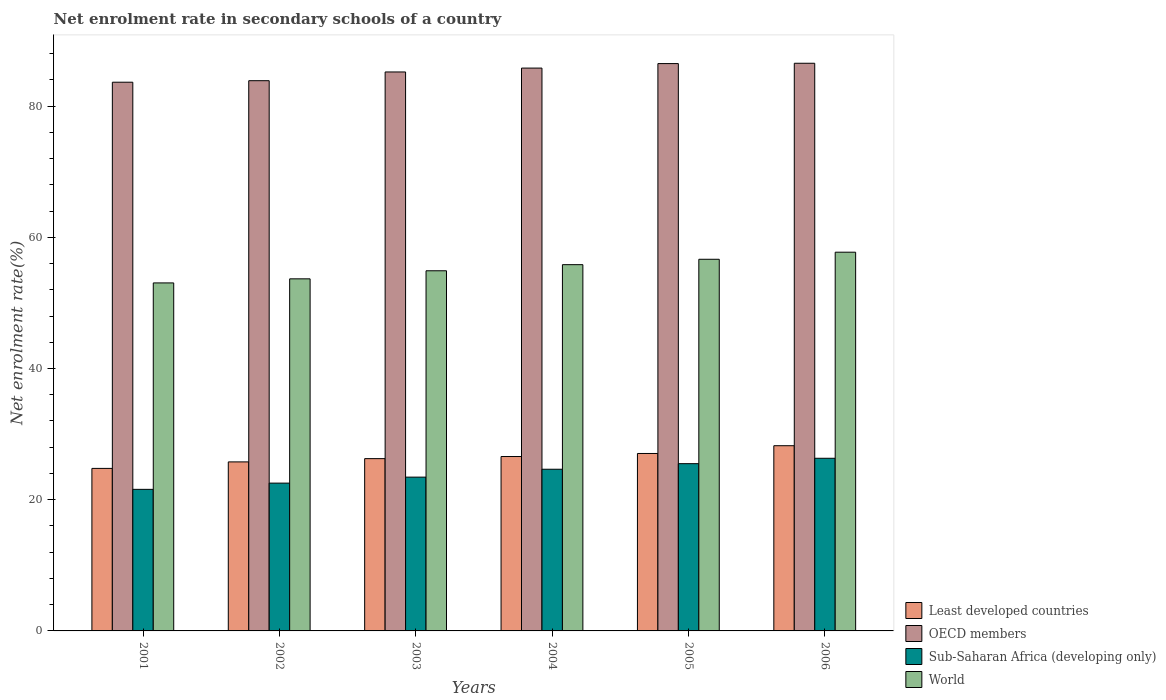How many groups of bars are there?
Your answer should be very brief. 6. Are the number of bars on each tick of the X-axis equal?
Provide a short and direct response. Yes. How many bars are there on the 2nd tick from the left?
Give a very brief answer. 4. How many bars are there on the 3rd tick from the right?
Ensure brevity in your answer.  4. What is the label of the 2nd group of bars from the left?
Provide a short and direct response. 2002. What is the net enrolment rate in secondary schools in Sub-Saharan Africa (developing only) in 2005?
Your answer should be very brief. 25.5. Across all years, what is the maximum net enrolment rate in secondary schools in Sub-Saharan Africa (developing only)?
Your answer should be compact. 26.32. Across all years, what is the minimum net enrolment rate in secondary schools in OECD members?
Give a very brief answer. 83.64. In which year was the net enrolment rate in secondary schools in World maximum?
Keep it short and to the point. 2006. In which year was the net enrolment rate in secondary schools in World minimum?
Keep it short and to the point. 2001. What is the total net enrolment rate in secondary schools in OECD members in the graph?
Offer a terse response. 511.53. What is the difference between the net enrolment rate in secondary schools in OECD members in 2004 and that in 2005?
Give a very brief answer. -0.69. What is the difference between the net enrolment rate in secondary schools in Least developed countries in 2002 and the net enrolment rate in secondary schools in World in 2004?
Make the answer very short. -30.06. What is the average net enrolment rate in secondary schools in OECD members per year?
Give a very brief answer. 85.25. In the year 2001, what is the difference between the net enrolment rate in secondary schools in World and net enrolment rate in secondary schools in Least developed countries?
Give a very brief answer. 28.28. What is the ratio of the net enrolment rate in secondary schools in OECD members in 2004 to that in 2005?
Ensure brevity in your answer.  0.99. Is the net enrolment rate in secondary schools in Sub-Saharan Africa (developing only) in 2005 less than that in 2006?
Make the answer very short. Yes. What is the difference between the highest and the second highest net enrolment rate in secondary schools in World?
Your answer should be compact. 1.08. What is the difference between the highest and the lowest net enrolment rate in secondary schools in World?
Ensure brevity in your answer.  4.68. In how many years, is the net enrolment rate in secondary schools in Least developed countries greater than the average net enrolment rate in secondary schools in Least developed countries taken over all years?
Your response must be concise. 3. Is the sum of the net enrolment rate in secondary schools in OECD members in 2005 and 2006 greater than the maximum net enrolment rate in secondary schools in Sub-Saharan Africa (developing only) across all years?
Offer a terse response. Yes. What does the 3rd bar from the left in 2005 represents?
Offer a terse response. Sub-Saharan Africa (developing only). What does the 2nd bar from the right in 2001 represents?
Give a very brief answer. Sub-Saharan Africa (developing only). How many years are there in the graph?
Keep it short and to the point. 6. What is the difference between two consecutive major ticks on the Y-axis?
Your answer should be compact. 20. Are the values on the major ticks of Y-axis written in scientific E-notation?
Your answer should be very brief. No. Does the graph contain any zero values?
Your response must be concise. No. Does the graph contain grids?
Provide a succinct answer. No. What is the title of the graph?
Make the answer very short. Net enrolment rate in secondary schools of a country. Does "Seychelles" appear as one of the legend labels in the graph?
Keep it short and to the point. No. What is the label or title of the X-axis?
Offer a terse response. Years. What is the label or title of the Y-axis?
Your response must be concise. Net enrolment rate(%). What is the Net enrolment rate(%) in Least developed countries in 2001?
Your response must be concise. 24.77. What is the Net enrolment rate(%) of OECD members in 2001?
Provide a succinct answer. 83.64. What is the Net enrolment rate(%) in Sub-Saharan Africa (developing only) in 2001?
Your answer should be very brief. 21.58. What is the Net enrolment rate(%) of World in 2001?
Your answer should be compact. 53.05. What is the Net enrolment rate(%) in Least developed countries in 2002?
Provide a short and direct response. 25.77. What is the Net enrolment rate(%) of OECD members in 2002?
Make the answer very short. 83.87. What is the Net enrolment rate(%) of Sub-Saharan Africa (developing only) in 2002?
Make the answer very short. 22.53. What is the Net enrolment rate(%) of World in 2002?
Keep it short and to the point. 53.67. What is the Net enrolment rate(%) of Least developed countries in 2003?
Provide a short and direct response. 26.26. What is the Net enrolment rate(%) in OECD members in 2003?
Make the answer very short. 85.2. What is the Net enrolment rate(%) of Sub-Saharan Africa (developing only) in 2003?
Provide a short and direct response. 23.44. What is the Net enrolment rate(%) in World in 2003?
Offer a terse response. 54.9. What is the Net enrolment rate(%) of Least developed countries in 2004?
Give a very brief answer. 26.58. What is the Net enrolment rate(%) of OECD members in 2004?
Provide a succinct answer. 85.8. What is the Net enrolment rate(%) of Sub-Saharan Africa (developing only) in 2004?
Provide a short and direct response. 24.64. What is the Net enrolment rate(%) of World in 2004?
Keep it short and to the point. 55.83. What is the Net enrolment rate(%) of Least developed countries in 2005?
Your answer should be compact. 27.05. What is the Net enrolment rate(%) in OECD members in 2005?
Offer a very short reply. 86.48. What is the Net enrolment rate(%) of Sub-Saharan Africa (developing only) in 2005?
Give a very brief answer. 25.5. What is the Net enrolment rate(%) in World in 2005?
Ensure brevity in your answer.  56.65. What is the Net enrolment rate(%) of Least developed countries in 2006?
Your answer should be very brief. 28.23. What is the Net enrolment rate(%) in OECD members in 2006?
Your answer should be very brief. 86.53. What is the Net enrolment rate(%) in Sub-Saharan Africa (developing only) in 2006?
Provide a short and direct response. 26.32. What is the Net enrolment rate(%) of World in 2006?
Offer a very short reply. 57.73. Across all years, what is the maximum Net enrolment rate(%) of Least developed countries?
Give a very brief answer. 28.23. Across all years, what is the maximum Net enrolment rate(%) in OECD members?
Provide a short and direct response. 86.53. Across all years, what is the maximum Net enrolment rate(%) of Sub-Saharan Africa (developing only)?
Your answer should be compact. 26.32. Across all years, what is the maximum Net enrolment rate(%) in World?
Offer a terse response. 57.73. Across all years, what is the minimum Net enrolment rate(%) in Least developed countries?
Offer a terse response. 24.77. Across all years, what is the minimum Net enrolment rate(%) in OECD members?
Your answer should be compact. 83.64. Across all years, what is the minimum Net enrolment rate(%) of Sub-Saharan Africa (developing only)?
Your answer should be compact. 21.58. Across all years, what is the minimum Net enrolment rate(%) of World?
Make the answer very short. 53.05. What is the total Net enrolment rate(%) in Least developed countries in the graph?
Offer a terse response. 158.67. What is the total Net enrolment rate(%) of OECD members in the graph?
Your answer should be very brief. 511.53. What is the total Net enrolment rate(%) in Sub-Saharan Africa (developing only) in the graph?
Provide a succinct answer. 144.01. What is the total Net enrolment rate(%) of World in the graph?
Offer a very short reply. 331.83. What is the difference between the Net enrolment rate(%) of Least developed countries in 2001 and that in 2002?
Give a very brief answer. -0.99. What is the difference between the Net enrolment rate(%) of OECD members in 2001 and that in 2002?
Your answer should be compact. -0.23. What is the difference between the Net enrolment rate(%) of Sub-Saharan Africa (developing only) in 2001 and that in 2002?
Your response must be concise. -0.95. What is the difference between the Net enrolment rate(%) in World in 2001 and that in 2002?
Keep it short and to the point. -0.62. What is the difference between the Net enrolment rate(%) of Least developed countries in 2001 and that in 2003?
Offer a very short reply. -1.49. What is the difference between the Net enrolment rate(%) of OECD members in 2001 and that in 2003?
Give a very brief answer. -1.56. What is the difference between the Net enrolment rate(%) of Sub-Saharan Africa (developing only) in 2001 and that in 2003?
Provide a succinct answer. -1.86. What is the difference between the Net enrolment rate(%) in World in 2001 and that in 2003?
Your response must be concise. -1.85. What is the difference between the Net enrolment rate(%) in Least developed countries in 2001 and that in 2004?
Your answer should be compact. -1.81. What is the difference between the Net enrolment rate(%) in OECD members in 2001 and that in 2004?
Ensure brevity in your answer.  -2.15. What is the difference between the Net enrolment rate(%) of Sub-Saharan Africa (developing only) in 2001 and that in 2004?
Provide a short and direct response. -3.06. What is the difference between the Net enrolment rate(%) in World in 2001 and that in 2004?
Provide a short and direct response. -2.78. What is the difference between the Net enrolment rate(%) in Least developed countries in 2001 and that in 2005?
Your response must be concise. -2.28. What is the difference between the Net enrolment rate(%) of OECD members in 2001 and that in 2005?
Your answer should be compact. -2.84. What is the difference between the Net enrolment rate(%) of Sub-Saharan Africa (developing only) in 2001 and that in 2005?
Your answer should be compact. -3.92. What is the difference between the Net enrolment rate(%) of World in 2001 and that in 2005?
Offer a very short reply. -3.6. What is the difference between the Net enrolment rate(%) of Least developed countries in 2001 and that in 2006?
Give a very brief answer. -3.46. What is the difference between the Net enrolment rate(%) of OECD members in 2001 and that in 2006?
Give a very brief answer. -2.89. What is the difference between the Net enrolment rate(%) in Sub-Saharan Africa (developing only) in 2001 and that in 2006?
Provide a succinct answer. -4.74. What is the difference between the Net enrolment rate(%) of World in 2001 and that in 2006?
Give a very brief answer. -4.68. What is the difference between the Net enrolment rate(%) in Least developed countries in 2002 and that in 2003?
Provide a short and direct response. -0.5. What is the difference between the Net enrolment rate(%) in OECD members in 2002 and that in 2003?
Ensure brevity in your answer.  -1.33. What is the difference between the Net enrolment rate(%) of Sub-Saharan Africa (developing only) in 2002 and that in 2003?
Your answer should be very brief. -0.91. What is the difference between the Net enrolment rate(%) of World in 2002 and that in 2003?
Keep it short and to the point. -1.23. What is the difference between the Net enrolment rate(%) of Least developed countries in 2002 and that in 2004?
Offer a very short reply. -0.82. What is the difference between the Net enrolment rate(%) of OECD members in 2002 and that in 2004?
Your answer should be very brief. -1.92. What is the difference between the Net enrolment rate(%) of Sub-Saharan Africa (developing only) in 2002 and that in 2004?
Your answer should be compact. -2.11. What is the difference between the Net enrolment rate(%) of World in 2002 and that in 2004?
Your response must be concise. -2.16. What is the difference between the Net enrolment rate(%) of Least developed countries in 2002 and that in 2005?
Keep it short and to the point. -1.28. What is the difference between the Net enrolment rate(%) of OECD members in 2002 and that in 2005?
Offer a terse response. -2.61. What is the difference between the Net enrolment rate(%) of Sub-Saharan Africa (developing only) in 2002 and that in 2005?
Provide a short and direct response. -2.97. What is the difference between the Net enrolment rate(%) of World in 2002 and that in 2005?
Provide a short and direct response. -2.98. What is the difference between the Net enrolment rate(%) of Least developed countries in 2002 and that in 2006?
Your answer should be compact. -2.47. What is the difference between the Net enrolment rate(%) of OECD members in 2002 and that in 2006?
Offer a very short reply. -2.66. What is the difference between the Net enrolment rate(%) of Sub-Saharan Africa (developing only) in 2002 and that in 2006?
Keep it short and to the point. -3.79. What is the difference between the Net enrolment rate(%) in World in 2002 and that in 2006?
Your response must be concise. -4.06. What is the difference between the Net enrolment rate(%) of Least developed countries in 2003 and that in 2004?
Make the answer very short. -0.32. What is the difference between the Net enrolment rate(%) of OECD members in 2003 and that in 2004?
Make the answer very short. -0.59. What is the difference between the Net enrolment rate(%) of Sub-Saharan Africa (developing only) in 2003 and that in 2004?
Provide a short and direct response. -1.2. What is the difference between the Net enrolment rate(%) of World in 2003 and that in 2004?
Make the answer very short. -0.93. What is the difference between the Net enrolment rate(%) of Least developed countries in 2003 and that in 2005?
Keep it short and to the point. -0.79. What is the difference between the Net enrolment rate(%) in OECD members in 2003 and that in 2005?
Ensure brevity in your answer.  -1.28. What is the difference between the Net enrolment rate(%) of Sub-Saharan Africa (developing only) in 2003 and that in 2005?
Provide a short and direct response. -2.05. What is the difference between the Net enrolment rate(%) of World in 2003 and that in 2005?
Ensure brevity in your answer.  -1.75. What is the difference between the Net enrolment rate(%) of Least developed countries in 2003 and that in 2006?
Your answer should be very brief. -1.97. What is the difference between the Net enrolment rate(%) in OECD members in 2003 and that in 2006?
Your response must be concise. -1.33. What is the difference between the Net enrolment rate(%) of Sub-Saharan Africa (developing only) in 2003 and that in 2006?
Provide a short and direct response. -2.87. What is the difference between the Net enrolment rate(%) in World in 2003 and that in 2006?
Your answer should be compact. -2.83. What is the difference between the Net enrolment rate(%) of Least developed countries in 2004 and that in 2005?
Make the answer very short. -0.46. What is the difference between the Net enrolment rate(%) in OECD members in 2004 and that in 2005?
Your response must be concise. -0.69. What is the difference between the Net enrolment rate(%) in Sub-Saharan Africa (developing only) in 2004 and that in 2005?
Make the answer very short. -0.85. What is the difference between the Net enrolment rate(%) of World in 2004 and that in 2005?
Provide a succinct answer. -0.82. What is the difference between the Net enrolment rate(%) of Least developed countries in 2004 and that in 2006?
Your response must be concise. -1.65. What is the difference between the Net enrolment rate(%) of OECD members in 2004 and that in 2006?
Your answer should be compact. -0.74. What is the difference between the Net enrolment rate(%) in Sub-Saharan Africa (developing only) in 2004 and that in 2006?
Offer a very short reply. -1.67. What is the difference between the Net enrolment rate(%) in World in 2004 and that in 2006?
Make the answer very short. -1.9. What is the difference between the Net enrolment rate(%) of Least developed countries in 2005 and that in 2006?
Provide a short and direct response. -1.18. What is the difference between the Net enrolment rate(%) of OECD members in 2005 and that in 2006?
Provide a succinct answer. -0.05. What is the difference between the Net enrolment rate(%) of Sub-Saharan Africa (developing only) in 2005 and that in 2006?
Keep it short and to the point. -0.82. What is the difference between the Net enrolment rate(%) of World in 2005 and that in 2006?
Give a very brief answer. -1.08. What is the difference between the Net enrolment rate(%) of Least developed countries in 2001 and the Net enrolment rate(%) of OECD members in 2002?
Your answer should be compact. -59.1. What is the difference between the Net enrolment rate(%) of Least developed countries in 2001 and the Net enrolment rate(%) of Sub-Saharan Africa (developing only) in 2002?
Make the answer very short. 2.24. What is the difference between the Net enrolment rate(%) in Least developed countries in 2001 and the Net enrolment rate(%) in World in 2002?
Your response must be concise. -28.9. What is the difference between the Net enrolment rate(%) in OECD members in 2001 and the Net enrolment rate(%) in Sub-Saharan Africa (developing only) in 2002?
Make the answer very short. 61.11. What is the difference between the Net enrolment rate(%) of OECD members in 2001 and the Net enrolment rate(%) of World in 2002?
Provide a short and direct response. 29.97. What is the difference between the Net enrolment rate(%) in Sub-Saharan Africa (developing only) in 2001 and the Net enrolment rate(%) in World in 2002?
Your answer should be very brief. -32.09. What is the difference between the Net enrolment rate(%) in Least developed countries in 2001 and the Net enrolment rate(%) in OECD members in 2003?
Provide a succinct answer. -60.43. What is the difference between the Net enrolment rate(%) in Least developed countries in 2001 and the Net enrolment rate(%) in Sub-Saharan Africa (developing only) in 2003?
Ensure brevity in your answer.  1.33. What is the difference between the Net enrolment rate(%) of Least developed countries in 2001 and the Net enrolment rate(%) of World in 2003?
Your answer should be compact. -30.13. What is the difference between the Net enrolment rate(%) of OECD members in 2001 and the Net enrolment rate(%) of Sub-Saharan Africa (developing only) in 2003?
Offer a terse response. 60.2. What is the difference between the Net enrolment rate(%) of OECD members in 2001 and the Net enrolment rate(%) of World in 2003?
Provide a short and direct response. 28.74. What is the difference between the Net enrolment rate(%) of Sub-Saharan Africa (developing only) in 2001 and the Net enrolment rate(%) of World in 2003?
Your answer should be very brief. -33.32. What is the difference between the Net enrolment rate(%) in Least developed countries in 2001 and the Net enrolment rate(%) in OECD members in 2004?
Your response must be concise. -61.02. What is the difference between the Net enrolment rate(%) of Least developed countries in 2001 and the Net enrolment rate(%) of Sub-Saharan Africa (developing only) in 2004?
Make the answer very short. 0.13. What is the difference between the Net enrolment rate(%) of Least developed countries in 2001 and the Net enrolment rate(%) of World in 2004?
Your answer should be very brief. -31.06. What is the difference between the Net enrolment rate(%) in OECD members in 2001 and the Net enrolment rate(%) in Sub-Saharan Africa (developing only) in 2004?
Make the answer very short. 59. What is the difference between the Net enrolment rate(%) in OECD members in 2001 and the Net enrolment rate(%) in World in 2004?
Make the answer very short. 27.81. What is the difference between the Net enrolment rate(%) of Sub-Saharan Africa (developing only) in 2001 and the Net enrolment rate(%) of World in 2004?
Provide a succinct answer. -34.25. What is the difference between the Net enrolment rate(%) in Least developed countries in 2001 and the Net enrolment rate(%) in OECD members in 2005?
Your answer should be very brief. -61.71. What is the difference between the Net enrolment rate(%) of Least developed countries in 2001 and the Net enrolment rate(%) of Sub-Saharan Africa (developing only) in 2005?
Your answer should be very brief. -0.72. What is the difference between the Net enrolment rate(%) in Least developed countries in 2001 and the Net enrolment rate(%) in World in 2005?
Your answer should be very brief. -31.88. What is the difference between the Net enrolment rate(%) of OECD members in 2001 and the Net enrolment rate(%) of Sub-Saharan Africa (developing only) in 2005?
Offer a terse response. 58.15. What is the difference between the Net enrolment rate(%) in OECD members in 2001 and the Net enrolment rate(%) in World in 2005?
Your answer should be very brief. 26.99. What is the difference between the Net enrolment rate(%) in Sub-Saharan Africa (developing only) in 2001 and the Net enrolment rate(%) in World in 2005?
Provide a short and direct response. -35.07. What is the difference between the Net enrolment rate(%) in Least developed countries in 2001 and the Net enrolment rate(%) in OECD members in 2006?
Offer a terse response. -61.76. What is the difference between the Net enrolment rate(%) of Least developed countries in 2001 and the Net enrolment rate(%) of Sub-Saharan Africa (developing only) in 2006?
Provide a succinct answer. -1.54. What is the difference between the Net enrolment rate(%) in Least developed countries in 2001 and the Net enrolment rate(%) in World in 2006?
Make the answer very short. -32.96. What is the difference between the Net enrolment rate(%) in OECD members in 2001 and the Net enrolment rate(%) in Sub-Saharan Africa (developing only) in 2006?
Your answer should be compact. 57.33. What is the difference between the Net enrolment rate(%) in OECD members in 2001 and the Net enrolment rate(%) in World in 2006?
Give a very brief answer. 25.91. What is the difference between the Net enrolment rate(%) of Sub-Saharan Africa (developing only) in 2001 and the Net enrolment rate(%) of World in 2006?
Your answer should be compact. -36.15. What is the difference between the Net enrolment rate(%) of Least developed countries in 2002 and the Net enrolment rate(%) of OECD members in 2003?
Your response must be concise. -59.44. What is the difference between the Net enrolment rate(%) of Least developed countries in 2002 and the Net enrolment rate(%) of Sub-Saharan Africa (developing only) in 2003?
Give a very brief answer. 2.32. What is the difference between the Net enrolment rate(%) in Least developed countries in 2002 and the Net enrolment rate(%) in World in 2003?
Offer a very short reply. -29.13. What is the difference between the Net enrolment rate(%) in OECD members in 2002 and the Net enrolment rate(%) in Sub-Saharan Africa (developing only) in 2003?
Provide a short and direct response. 60.43. What is the difference between the Net enrolment rate(%) of OECD members in 2002 and the Net enrolment rate(%) of World in 2003?
Keep it short and to the point. 28.97. What is the difference between the Net enrolment rate(%) of Sub-Saharan Africa (developing only) in 2002 and the Net enrolment rate(%) of World in 2003?
Keep it short and to the point. -32.37. What is the difference between the Net enrolment rate(%) in Least developed countries in 2002 and the Net enrolment rate(%) in OECD members in 2004?
Give a very brief answer. -60.03. What is the difference between the Net enrolment rate(%) in Least developed countries in 2002 and the Net enrolment rate(%) in Sub-Saharan Africa (developing only) in 2004?
Ensure brevity in your answer.  1.12. What is the difference between the Net enrolment rate(%) in Least developed countries in 2002 and the Net enrolment rate(%) in World in 2004?
Your answer should be compact. -30.06. What is the difference between the Net enrolment rate(%) of OECD members in 2002 and the Net enrolment rate(%) of Sub-Saharan Africa (developing only) in 2004?
Provide a succinct answer. 59.23. What is the difference between the Net enrolment rate(%) in OECD members in 2002 and the Net enrolment rate(%) in World in 2004?
Give a very brief answer. 28.04. What is the difference between the Net enrolment rate(%) in Sub-Saharan Africa (developing only) in 2002 and the Net enrolment rate(%) in World in 2004?
Your answer should be very brief. -33.3. What is the difference between the Net enrolment rate(%) of Least developed countries in 2002 and the Net enrolment rate(%) of OECD members in 2005?
Offer a very short reply. -60.72. What is the difference between the Net enrolment rate(%) in Least developed countries in 2002 and the Net enrolment rate(%) in Sub-Saharan Africa (developing only) in 2005?
Provide a succinct answer. 0.27. What is the difference between the Net enrolment rate(%) of Least developed countries in 2002 and the Net enrolment rate(%) of World in 2005?
Provide a succinct answer. -30.89. What is the difference between the Net enrolment rate(%) in OECD members in 2002 and the Net enrolment rate(%) in Sub-Saharan Africa (developing only) in 2005?
Offer a terse response. 58.38. What is the difference between the Net enrolment rate(%) of OECD members in 2002 and the Net enrolment rate(%) of World in 2005?
Your response must be concise. 27.22. What is the difference between the Net enrolment rate(%) of Sub-Saharan Africa (developing only) in 2002 and the Net enrolment rate(%) of World in 2005?
Ensure brevity in your answer.  -34.12. What is the difference between the Net enrolment rate(%) in Least developed countries in 2002 and the Net enrolment rate(%) in OECD members in 2006?
Make the answer very short. -60.77. What is the difference between the Net enrolment rate(%) in Least developed countries in 2002 and the Net enrolment rate(%) in Sub-Saharan Africa (developing only) in 2006?
Your response must be concise. -0.55. What is the difference between the Net enrolment rate(%) of Least developed countries in 2002 and the Net enrolment rate(%) of World in 2006?
Provide a succinct answer. -31.96. What is the difference between the Net enrolment rate(%) in OECD members in 2002 and the Net enrolment rate(%) in Sub-Saharan Africa (developing only) in 2006?
Keep it short and to the point. 57.56. What is the difference between the Net enrolment rate(%) in OECD members in 2002 and the Net enrolment rate(%) in World in 2006?
Give a very brief answer. 26.14. What is the difference between the Net enrolment rate(%) in Sub-Saharan Africa (developing only) in 2002 and the Net enrolment rate(%) in World in 2006?
Your answer should be compact. -35.2. What is the difference between the Net enrolment rate(%) in Least developed countries in 2003 and the Net enrolment rate(%) in OECD members in 2004?
Ensure brevity in your answer.  -59.53. What is the difference between the Net enrolment rate(%) of Least developed countries in 2003 and the Net enrolment rate(%) of Sub-Saharan Africa (developing only) in 2004?
Your response must be concise. 1.62. What is the difference between the Net enrolment rate(%) in Least developed countries in 2003 and the Net enrolment rate(%) in World in 2004?
Give a very brief answer. -29.57. What is the difference between the Net enrolment rate(%) of OECD members in 2003 and the Net enrolment rate(%) of Sub-Saharan Africa (developing only) in 2004?
Your answer should be compact. 60.56. What is the difference between the Net enrolment rate(%) of OECD members in 2003 and the Net enrolment rate(%) of World in 2004?
Ensure brevity in your answer.  29.37. What is the difference between the Net enrolment rate(%) in Sub-Saharan Africa (developing only) in 2003 and the Net enrolment rate(%) in World in 2004?
Your answer should be very brief. -32.39. What is the difference between the Net enrolment rate(%) in Least developed countries in 2003 and the Net enrolment rate(%) in OECD members in 2005?
Give a very brief answer. -60.22. What is the difference between the Net enrolment rate(%) of Least developed countries in 2003 and the Net enrolment rate(%) of Sub-Saharan Africa (developing only) in 2005?
Your response must be concise. 0.77. What is the difference between the Net enrolment rate(%) in Least developed countries in 2003 and the Net enrolment rate(%) in World in 2005?
Provide a short and direct response. -30.39. What is the difference between the Net enrolment rate(%) in OECD members in 2003 and the Net enrolment rate(%) in Sub-Saharan Africa (developing only) in 2005?
Offer a very short reply. 59.71. What is the difference between the Net enrolment rate(%) of OECD members in 2003 and the Net enrolment rate(%) of World in 2005?
Provide a short and direct response. 28.55. What is the difference between the Net enrolment rate(%) of Sub-Saharan Africa (developing only) in 2003 and the Net enrolment rate(%) of World in 2005?
Give a very brief answer. -33.21. What is the difference between the Net enrolment rate(%) in Least developed countries in 2003 and the Net enrolment rate(%) in OECD members in 2006?
Offer a terse response. -60.27. What is the difference between the Net enrolment rate(%) in Least developed countries in 2003 and the Net enrolment rate(%) in Sub-Saharan Africa (developing only) in 2006?
Your answer should be compact. -0.05. What is the difference between the Net enrolment rate(%) in Least developed countries in 2003 and the Net enrolment rate(%) in World in 2006?
Ensure brevity in your answer.  -31.47. What is the difference between the Net enrolment rate(%) in OECD members in 2003 and the Net enrolment rate(%) in Sub-Saharan Africa (developing only) in 2006?
Ensure brevity in your answer.  58.89. What is the difference between the Net enrolment rate(%) in OECD members in 2003 and the Net enrolment rate(%) in World in 2006?
Ensure brevity in your answer.  27.47. What is the difference between the Net enrolment rate(%) of Sub-Saharan Africa (developing only) in 2003 and the Net enrolment rate(%) of World in 2006?
Keep it short and to the point. -34.29. What is the difference between the Net enrolment rate(%) of Least developed countries in 2004 and the Net enrolment rate(%) of OECD members in 2005?
Keep it short and to the point. -59.9. What is the difference between the Net enrolment rate(%) of Least developed countries in 2004 and the Net enrolment rate(%) of Sub-Saharan Africa (developing only) in 2005?
Keep it short and to the point. 1.09. What is the difference between the Net enrolment rate(%) of Least developed countries in 2004 and the Net enrolment rate(%) of World in 2005?
Give a very brief answer. -30.07. What is the difference between the Net enrolment rate(%) in OECD members in 2004 and the Net enrolment rate(%) in Sub-Saharan Africa (developing only) in 2005?
Your response must be concise. 60.3. What is the difference between the Net enrolment rate(%) of OECD members in 2004 and the Net enrolment rate(%) of World in 2005?
Offer a very short reply. 29.14. What is the difference between the Net enrolment rate(%) of Sub-Saharan Africa (developing only) in 2004 and the Net enrolment rate(%) of World in 2005?
Your response must be concise. -32.01. What is the difference between the Net enrolment rate(%) in Least developed countries in 2004 and the Net enrolment rate(%) in OECD members in 2006?
Offer a very short reply. -59.95. What is the difference between the Net enrolment rate(%) of Least developed countries in 2004 and the Net enrolment rate(%) of Sub-Saharan Africa (developing only) in 2006?
Your answer should be very brief. 0.27. What is the difference between the Net enrolment rate(%) in Least developed countries in 2004 and the Net enrolment rate(%) in World in 2006?
Keep it short and to the point. -31.15. What is the difference between the Net enrolment rate(%) in OECD members in 2004 and the Net enrolment rate(%) in Sub-Saharan Africa (developing only) in 2006?
Ensure brevity in your answer.  59.48. What is the difference between the Net enrolment rate(%) of OECD members in 2004 and the Net enrolment rate(%) of World in 2006?
Offer a very short reply. 28.07. What is the difference between the Net enrolment rate(%) of Sub-Saharan Africa (developing only) in 2004 and the Net enrolment rate(%) of World in 2006?
Make the answer very short. -33.09. What is the difference between the Net enrolment rate(%) of Least developed countries in 2005 and the Net enrolment rate(%) of OECD members in 2006?
Keep it short and to the point. -59.48. What is the difference between the Net enrolment rate(%) of Least developed countries in 2005 and the Net enrolment rate(%) of Sub-Saharan Africa (developing only) in 2006?
Ensure brevity in your answer.  0.73. What is the difference between the Net enrolment rate(%) of Least developed countries in 2005 and the Net enrolment rate(%) of World in 2006?
Keep it short and to the point. -30.68. What is the difference between the Net enrolment rate(%) in OECD members in 2005 and the Net enrolment rate(%) in Sub-Saharan Africa (developing only) in 2006?
Ensure brevity in your answer.  60.17. What is the difference between the Net enrolment rate(%) of OECD members in 2005 and the Net enrolment rate(%) of World in 2006?
Your response must be concise. 28.75. What is the difference between the Net enrolment rate(%) of Sub-Saharan Africa (developing only) in 2005 and the Net enrolment rate(%) of World in 2006?
Ensure brevity in your answer.  -32.23. What is the average Net enrolment rate(%) in Least developed countries per year?
Provide a short and direct response. 26.44. What is the average Net enrolment rate(%) of OECD members per year?
Make the answer very short. 85.25. What is the average Net enrolment rate(%) of Sub-Saharan Africa (developing only) per year?
Provide a succinct answer. 24. What is the average Net enrolment rate(%) of World per year?
Provide a short and direct response. 55.3. In the year 2001, what is the difference between the Net enrolment rate(%) in Least developed countries and Net enrolment rate(%) in OECD members?
Offer a terse response. -58.87. In the year 2001, what is the difference between the Net enrolment rate(%) of Least developed countries and Net enrolment rate(%) of Sub-Saharan Africa (developing only)?
Your response must be concise. 3.19. In the year 2001, what is the difference between the Net enrolment rate(%) of Least developed countries and Net enrolment rate(%) of World?
Provide a succinct answer. -28.28. In the year 2001, what is the difference between the Net enrolment rate(%) of OECD members and Net enrolment rate(%) of Sub-Saharan Africa (developing only)?
Your response must be concise. 62.06. In the year 2001, what is the difference between the Net enrolment rate(%) of OECD members and Net enrolment rate(%) of World?
Provide a short and direct response. 30.59. In the year 2001, what is the difference between the Net enrolment rate(%) of Sub-Saharan Africa (developing only) and Net enrolment rate(%) of World?
Your answer should be very brief. -31.47. In the year 2002, what is the difference between the Net enrolment rate(%) of Least developed countries and Net enrolment rate(%) of OECD members?
Provide a succinct answer. -58.11. In the year 2002, what is the difference between the Net enrolment rate(%) of Least developed countries and Net enrolment rate(%) of Sub-Saharan Africa (developing only)?
Give a very brief answer. 3.24. In the year 2002, what is the difference between the Net enrolment rate(%) in Least developed countries and Net enrolment rate(%) in World?
Keep it short and to the point. -27.9. In the year 2002, what is the difference between the Net enrolment rate(%) of OECD members and Net enrolment rate(%) of Sub-Saharan Africa (developing only)?
Provide a succinct answer. 61.34. In the year 2002, what is the difference between the Net enrolment rate(%) in OECD members and Net enrolment rate(%) in World?
Make the answer very short. 30.2. In the year 2002, what is the difference between the Net enrolment rate(%) of Sub-Saharan Africa (developing only) and Net enrolment rate(%) of World?
Offer a very short reply. -31.14. In the year 2003, what is the difference between the Net enrolment rate(%) in Least developed countries and Net enrolment rate(%) in OECD members?
Your answer should be very brief. -58.94. In the year 2003, what is the difference between the Net enrolment rate(%) in Least developed countries and Net enrolment rate(%) in Sub-Saharan Africa (developing only)?
Offer a terse response. 2.82. In the year 2003, what is the difference between the Net enrolment rate(%) of Least developed countries and Net enrolment rate(%) of World?
Make the answer very short. -28.64. In the year 2003, what is the difference between the Net enrolment rate(%) in OECD members and Net enrolment rate(%) in Sub-Saharan Africa (developing only)?
Keep it short and to the point. 61.76. In the year 2003, what is the difference between the Net enrolment rate(%) in OECD members and Net enrolment rate(%) in World?
Give a very brief answer. 30.31. In the year 2003, what is the difference between the Net enrolment rate(%) of Sub-Saharan Africa (developing only) and Net enrolment rate(%) of World?
Provide a succinct answer. -31.46. In the year 2004, what is the difference between the Net enrolment rate(%) in Least developed countries and Net enrolment rate(%) in OECD members?
Offer a very short reply. -59.21. In the year 2004, what is the difference between the Net enrolment rate(%) of Least developed countries and Net enrolment rate(%) of Sub-Saharan Africa (developing only)?
Keep it short and to the point. 1.94. In the year 2004, what is the difference between the Net enrolment rate(%) in Least developed countries and Net enrolment rate(%) in World?
Ensure brevity in your answer.  -29.25. In the year 2004, what is the difference between the Net enrolment rate(%) in OECD members and Net enrolment rate(%) in Sub-Saharan Africa (developing only)?
Give a very brief answer. 61.15. In the year 2004, what is the difference between the Net enrolment rate(%) of OECD members and Net enrolment rate(%) of World?
Make the answer very short. 29.97. In the year 2004, what is the difference between the Net enrolment rate(%) in Sub-Saharan Africa (developing only) and Net enrolment rate(%) in World?
Your answer should be very brief. -31.19. In the year 2005, what is the difference between the Net enrolment rate(%) in Least developed countries and Net enrolment rate(%) in OECD members?
Provide a succinct answer. -59.43. In the year 2005, what is the difference between the Net enrolment rate(%) of Least developed countries and Net enrolment rate(%) of Sub-Saharan Africa (developing only)?
Make the answer very short. 1.55. In the year 2005, what is the difference between the Net enrolment rate(%) in Least developed countries and Net enrolment rate(%) in World?
Your response must be concise. -29.6. In the year 2005, what is the difference between the Net enrolment rate(%) in OECD members and Net enrolment rate(%) in Sub-Saharan Africa (developing only)?
Your answer should be compact. 60.99. In the year 2005, what is the difference between the Net enrolment rate(%) of OECD members and Net enrolment rate(%) of World?
Offer a terse response. 29.83. In the year 2005, what is the difference between the Net enrolment rate(%) in Sub-Saharan Africa (developing only) and Net enrolment rate(%) in World?
Make the answer very short. -31.16. In the year 2006, what is the difference between the Net enrolment rate(%) in Least developed countries and Net enrolment rate(%) in OECD members?
Provide a succinct answer. -58.3. In the year 2006, what is the difference between the Net enrolment rate(%) in Least developed countries and Net enrolment rate(%) in Sub-Saharan Africa (developing only)?
Offer a very short reply. 1.92. In the year 2006, what is the difference between the Net enrolment rate(%) of Least developed countries and Net enrolment rate(%) of World?
Make the answer very short. -29.5. In the year 2006, what is the difference between the Net enrolment rate(%) in OECD members and Net enrolment rate(%) in Sub-Saharan Africa (developing only)?
Your response must be concise. 60.21. In the year 2006, what is the difference between the Net enrolment rate(%) in OECD members and Net enrolment rate(%) in World?
Your response must be concise. 28.8. In the year 2006, what is the difference between the Net enrolment rate(%) of Sub-Saharan Africa (developing only) and Net enrolment rate(%) of World?
Offer a very short reply. -31.41. What is the ratio of the Net enrolment rate(%) of Least developed countries in 2001 to that in 2002?
Keep it short and to the point. 0.96. What is the ratio of the Net enrolment rate(%) of OECD members in 2001 to that in 2002?
Ensure brevity in your answer.  1. What is the ratio of the Net enrolment rate(%) of Sub-Saharan Africa (developing only) in 2001 to that in 2002?
Give a very brief answer. 0.96. What is the ratio of the Net enrolment rate(%) of World in 2001 to that in 2002?
Provide a succinct answer. 0.99. What is the ratio of the Net enrolment rate(%) in Least developed countries in 2001 to that in 2003?
Give a very brief answer. 0.94. What is the ratio of the Net enrolment rate(%) in OECD members in 2001 to that in 2003?
Give a very brief answer. 0.98. What is the ratio of the Net enrolment rate(%) of Sub-Saharan Africa (developing only) in 2001 to that in 2003?
Keep it short and to the point. 0.92. What is the ratio of the Net enrolment rate(%) in World in 2001 to that in 2003?
Your response must be concise. 0.97. What is the ratio of the Net enrolment rate(%) in Least developed countries in 2001 to that in 2004?
Offer a terse response. 0.93. What is the ratio of the Net enrolment rate(%) of OECD members in 2001 to that in 2004?
Make the answer very short. 0.97. What is the ratio of the Net enrolment rate(%) in Sub-Saharan Africa (developing only) in 2001 to that in 2004?
Make the answer very short. 0.88. What is the ratio of the Net enrolment rate(%) of World in 2001 to that in 2004?
Offer a terse response. 0.95. What is the ratio of the Net enrolment rate(%) in Least developed countries in 2001 to that in 2005?
Make the answer very short. 0.92. What is the ratio of the Net enrolment rate(%) in OECD members in 2001 to that in 2005?
Ensure brevity in your answer.  0.97. What is the ratio of the Net enrolment rate(%) of Sub-Saharan Africa (developing only) in 2001 to that in 2005?
Provide a succinct answer. 0.85. What is the ratio of the Net enrolment rate(%) of World in 2001 to that in 2005?
Provide a succinct answer. 0.94. What is the ratio of the Net enrolment rate(%) in Least developed countries in 2001 to that in 2006?
Your answer should be very brief. 0.88. What is the ratio of the Net enrolment rate(%) in OECD members in 2001 to that in 2006?
Give a very brief answer. 0.97. What is the ratio of the Net enrolment rate(%) of Sub-Saharan Africa (developing only) in 2001 to that in 2006?
Your response must be concise. 0.82. What is the ratio of the Net enrolment rate(%) in World in 2001 to that in 2006?
Offer a terse response. 0.92. What is the ratio of the Net enrolment rate(%) in Least developed countries in 2002 to that in 2003?
Give a very brief answer. 0.98. What is the ratio of the Net enrolment rate(%) of OECD members in 2002 to that in 2003?
Make the answer very short. 0.98. What is the ratio of the Net enrolment rate(%) in Sub-Saharan Africa (developing only) in 2002 to that in 2003?
Your response must be concise. 0.96. What is the ratio of the Net enrolment rate(%) in World in 2002 to that in 2003?
Give a very brief answer. 0.98. What is the ratio of the Net enrolment rate(%) in Least developed countries in 2002 to that in 2004?
Offer a terse response. 0.97. What is the ratio of the Net enrolment rate(%) in OECD members in 2002 to that in 2004?
Keep it short and to the point. 0.98. What is the ratio of the Net enrolment rate(%) of Sub-Saharan Africa (developing only) in 2002 to that in 2004?
Provide a succinct answer. 0.91. What is the ratio of the Net enrolment rate(%) in World in 2002 to that in 2004?
Make the answer very short. 0.96. What is the ratio of the Net enrolment rate(%) in Least developed countries in 2002 to that in 2005?
Give a very brief answer. 0.95. What is the ratio of the Net enrolment rate(%) in OECD members in 2002 to that in 2005?
Keep it short and to the point. 0.97. What is the ratio of the Net enrolment rate(%) in Sub-Saharan Africa (developing only) in 2002 to that in 2005?
Make the answer very short. 0.88. What is the ratio of the Net enrolment rate(%) of Least developed countries in 2002 to that in 2006?
Give a very brief answer. 0.91. What is the ratio of the Net enrolment rate(%) of OECD members in 2002 to that in 2006?
Keep it short and to the point. 0.97. What is the ratio of the Net enrolment rate(%) in Sub-Saharan Africa (developing only) in 2002 to that in 2006?
Provide a succinct answer. 0.86. What is the ratio of the Net enrolment rate(%) in World in 2002 to that in 2006?
Your answer should be compact. 0.93. What is the ratio of the Net enrolment rate(%) of Least developed countries in 2003 to that in 2004?
Provide a succinct answer. 0.99. What is the ratio of the Net enrolment rate(%) in Sub-Saharan Africa (developing only) in 2003 to that in 2004?
Your answer should be compact. 0.95. What is the ratio of the Net enrolment rate(%) in World in 2003 to that in 2004?
Your answer should be very brief. 0.98. What is the ratio of the Net enrolment rate(%) of Least developed countries in 2003 to that in 2005?
Your answer should be compact. 0.97. What is the ratio of the Net enrolment rate(%) of OECD members in 2003 to that in 2005?
Keep it short and to the point. 0.99. What is the ratio of the Net enrolment rate(%) in Sub-Saharan Africa (developing only) in 2003 to that in 2005?
Your answer should be very brief. 0.92. What is the ratio of the Net enrolment rate(%) of World in 2003 to that in 2005?
Ensure brevity in your answer.  0.97. What is the ratio of the Net enrolment rate(%) of Least developed countries in 2003 to that in 2006?
Give a very brief answer. 0.93. What is the ratio of the Net enrolment rate(%) in OECD members in 2003 to that in 2006?
Make the answer very short. 0.98. What is the ratio of the Net enrolment rate(%) of Sub-Saharan Africa (developing only) in 2003 to that in 2006?
Offer a terse response. 0.89. What is the ratio of the Net enrolment rate(%) in World in 2003 to that in 2006?
Provide a short and direct response. 0.95. What is the ratio of the Net enrolment rate(%) of Least developed countries in 2004 to that in 2005?
Offer a terse response. 0.98. What is the ratio of the Net enrolment rate(%) in OECD members in 2004 to that in 2005?
Offer a terse response. 0.99. What is the ratio of the Net enrolment rate(%) in Sub-Saharan Africa (developing only) in 2004 to that in 2005?
Make the answer very short. 0.97. What is the ratio of the Net enrolment rate(%) in World in 2004 to that in 2005?
Your answer should be very brief. 0.99. What is the ratio of the Net enrolment rate(%) in Least developed countries in 2004 to that in 2006?
Provide a short and direct response. 0.94. What is the ratio of the Net enrolment rate(%) of OECD members in 2004 to that in 2006?
Make the answer very short. 0.99. What is the ratio of the Net enrolment rate(%) in Sub-Saharan Africa (developing only) in 2004 to that in 2006?
Provide a succinct answer. 0.94. What is the ratio of the Net enrolment rate(%) in World in 2004 to that in 2006?
Provide a succinct answer. 0.97. What is the ratio of the Net enrolment rate(%) of Least developed countries in 2005 to that in 2006?
Your response must be concise. 0.96. What is the ratio of the Net enrolment rate(%) in OECD members in 2005 to that in 2006?
Your response must be concise. 1. What is the ratio of the Net enrolment rate(%) of Sub-Saharan Africa (developing only) in 2005 to that in 2006?
Keep it short and to the point. 0.97. What is the ratio of the Net enrolment rate(%) in World in 2005 to that in 2006?
Give a very brief answer. 0.98. What is the difference between the highest and the second highest Net enrolment rate(%) in Least developed countries?
Your response must be concise. 1.18. What is the difference between the highest and the second highest Net enrolment rate(%) in OECD members?
Give a very brief answer. 0.05. What is the difference between the highest and the second highest Net enrolment rate(%) in Sub-Saharan Africa (developing only)?
Your response must be concise. 0.82. What is the difference between the highest and the second highest Net enrolment rate(%) of World?
Ensure brevity in your answer.  1.08. What is the difference between the highest and the lowest Net enrolment rate(%) of Least developed countries?
Your answer should be very brief. 3.46. What is the difference between the highest and the lowest Net enrolment rate(%) of OECD members?
Your response must be concise. 2.89. What is the difference between the highest and the lowest Net enrolment rate(%) in Sub-Saharan Africa (developing only)?
Make the answer very short. 4.74. What is the difference between the highest and the lowest Net enrolment rate(%) of World?
Ensure brevity in your answer.  4.68. 